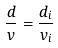Convert formula to latex. <formula><loc_0><loc_0><loc_500><loc_500>\frac { d } { v } = \frac { d _ { i } } { v _ { i } }</formula> 